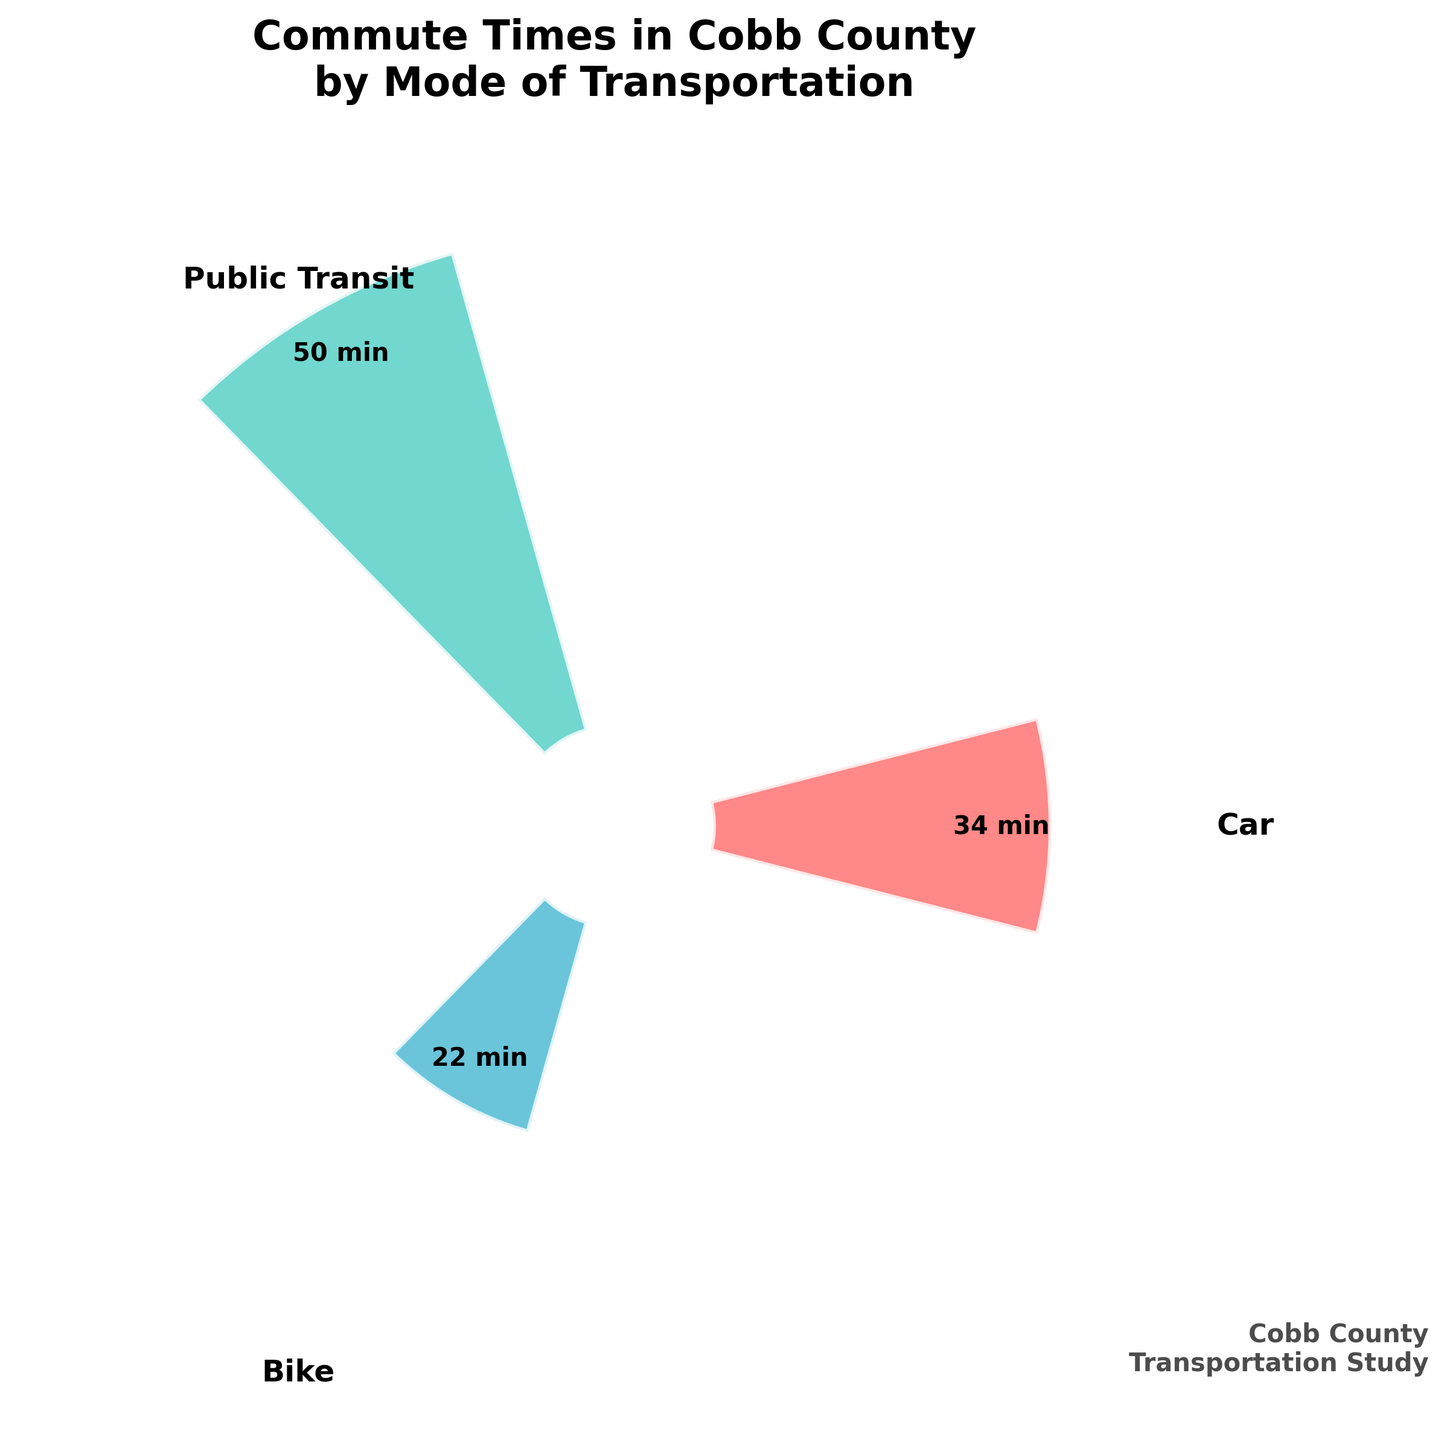what is the mode of transportation with the longest average commute time? The figure shows 'Public Transit' has the highest bar, indicating it has the longest average commute time.
Answer: Public Transit What are the average commute times for cars and bikes? By looking at the figure, the bars for 'Car' and 'Bike' show labels indicating their average commute times as 34 and 22 minutes respectively.
Answer: 34 min for Car, 22 min for Bike How much longer is the average commute time for public transit compared to biking? The average commute time for public transit is 50 minutes and for biking is 22 minutes. The difference is 50 - 22 = 28 minutes.
Answer: 28 minutes What is the title of the figure, and what information does it convey? The title at the top of the figure is 'Commute Times in Cobb County by Mode of Transportation,' indicating it compares average commute times for different transportation modes in Cobb County.
Answer: Commute Times in Cobb County by Mode of Transportation Which mode of transportation has the shortest average commute time? The 'Bike' mode has the shortest bar, indicating the shortest average commute time as shown in the figure.
Answer: Bike What is the sum of the average commute times for all three modes of transportation? The average commute times are 34 (Car), 50 (Public Transit), and 22 (Bike). Adding them: 34 + 50 + 22 = 106 minutes.
Answer: 106 minutes How many modes of transportation are displayed in the figure? The figure shows three different bars, representing three modes: Car, Public Transit, and Bike.
Answer: 3 Are the average commute times for all modes of transportation greater than 20 minutes? The figure shows the average commute times for Car (34), Public Transit (50), and Bike (22). All of these values are greater than 20 minutes.
Answer: Yes Which color represents public transit, and what does the bar signify? The bar representing 'Public Transit' is color-coded with a unique color (teal). This bar signifies the highest average commute time among the three modes.
Answer: teal, highest average commute time 